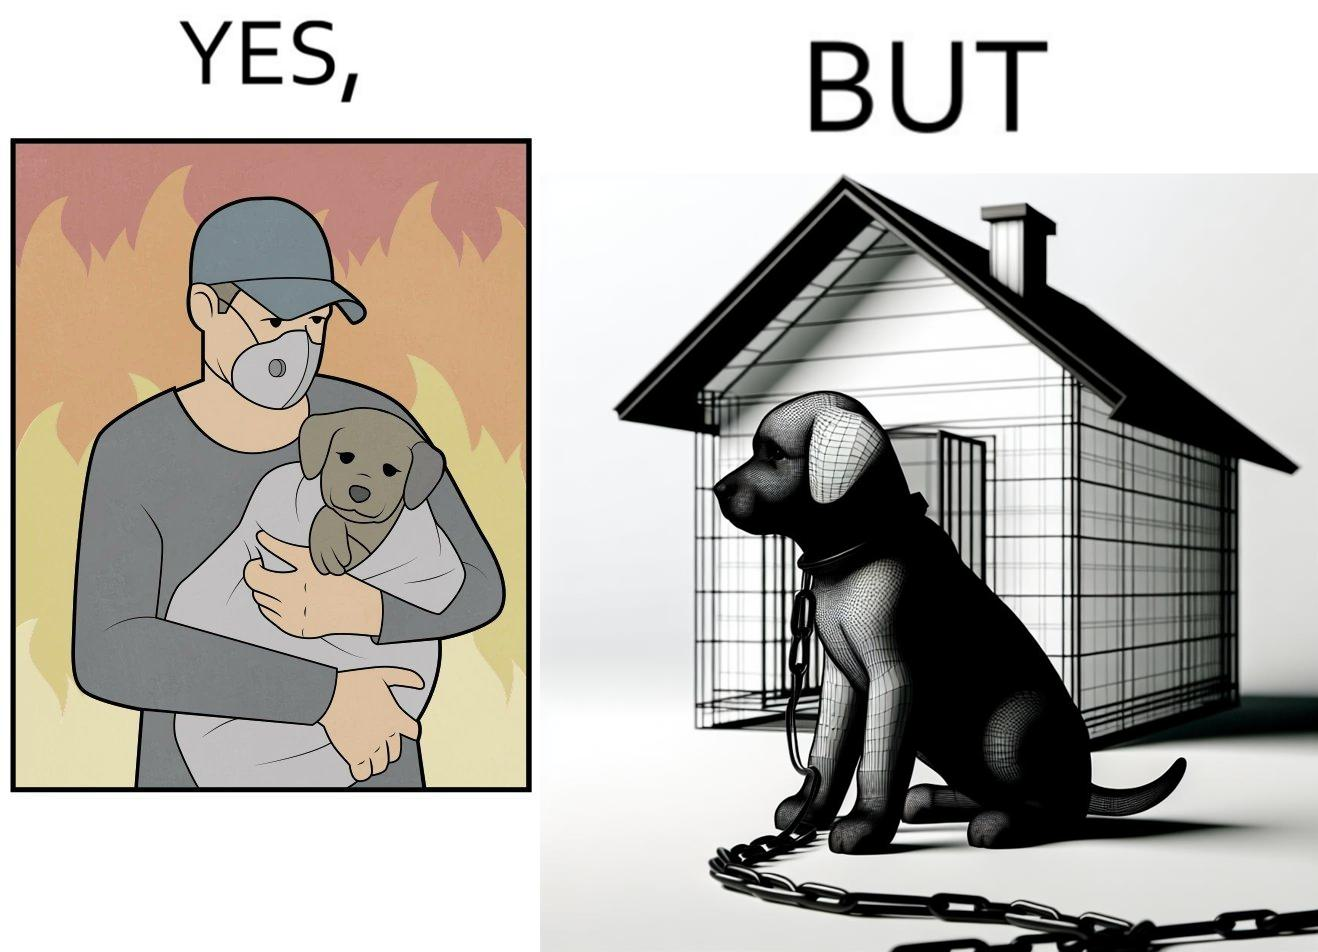Describe the contrast between the left and right parts of this image. In the left part of the image: a man, wearing mask, protecting a puppy from fire, in the background, by covering it in a sheet of cloth In the right part of the image: a puppy chained to a kennel 